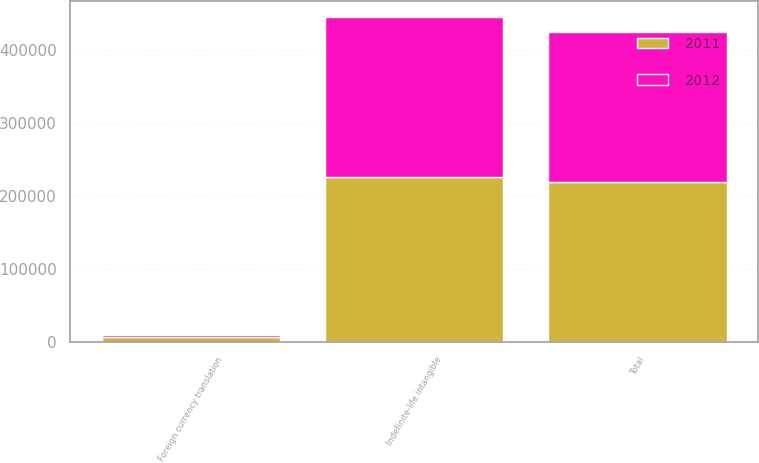Convert chart to OTSL. <chart><loc_0><loc_0><loc_500><loc_500><stacked_bar_chart><ecel><fcel>Indefinite-life intangible<fcel>Foreign currency translation<fcel>Total<nl><fcel>2012<fcel>218883<fcel>3339<fcel>204866<nl><fcel>2011<fcel>225679<fcel>6796<fcel>218883<nl></chart> 